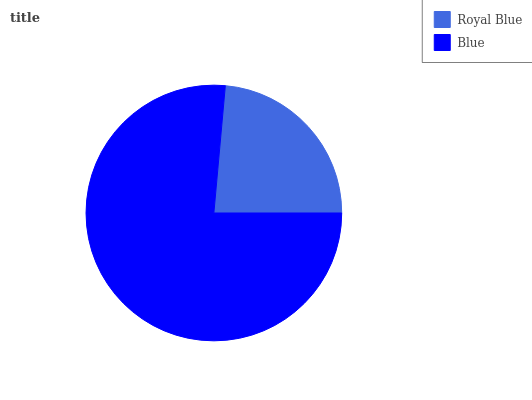Is Royal Blue the minimum?
Answer yes or no. Yes. Is Blue the maximum?
Answer yes or no. Yes. Is Blue the minimum?
Answer yes or no. No. Is Blue greater than Royal Blue?
Answer yes or no. Yes. Is Royal Blue less than Blue?
Answer yes or no. Yes. Is Royal Blue greater than Blue?
Answer yes or no. No. Is Blue less than Royal Blue?
Answer yes or no. No. Is Blue the high median?
Answer yes or no. Yes. Is Royal Blue the low median?
Answer yes or no. Yes. Is Royal Blue the high median?
Answer yes or no. No. Is Blue the low median?
Answer yes or no. No. 